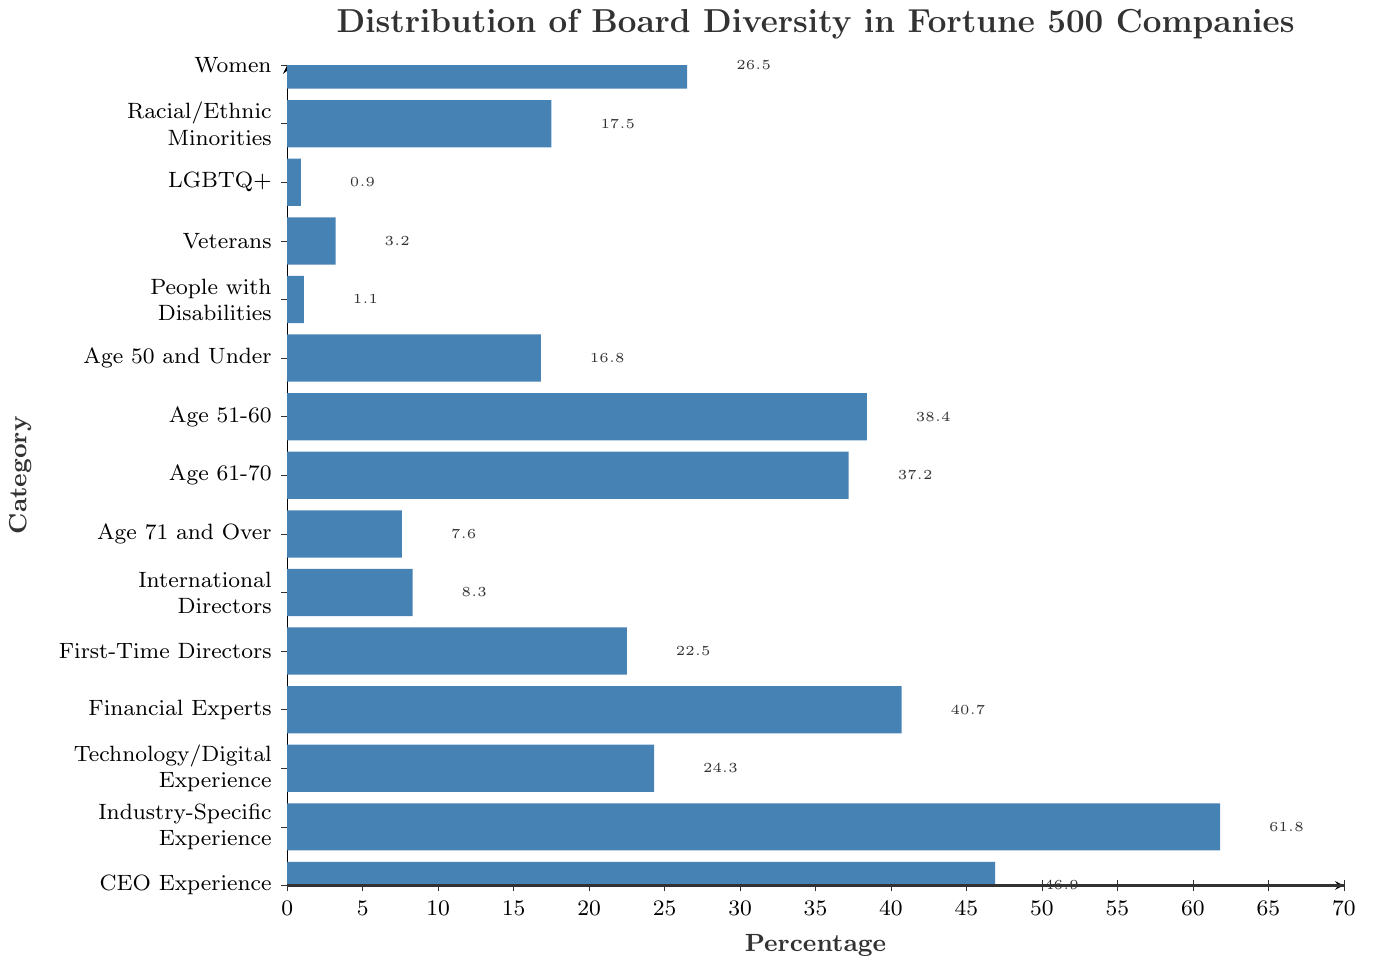Which category has the highest percentage? The highest bar represents the category with the highest percentage. The "Industry-Specific Experience" category has the highest bar at 61.8%.
Answer: Industry-Specific Experience What is the total percentage of directors with Age 51-60 and Age 61-70? Add the percentages of directors with Age 51-60 (38.4%) and Age 61-70 (37.2%). The sum is 38.4 + 37.2 = 75.6%.
Answer: 75.6% Compare the percentage of Women with that of Racial/Ethnic Minorities. Which is higher, and by how much? The percentage of Women is 26.5%, and that of Racial/Ethnic Minorities is 17.5%. The difference is 26.5 - 17.5 = 9%. Women have a higher percentage by 9%.
Answer: Women are higher by 9% Which category has the lowest representation? The shortest bar represents the category with the lowest percentage, which is the LGBTQ+ category at 0.9%.
Answer: LGBTQ+ Is the percentage of First-Time Directors greater than or less than the percentage of Financial Experts? The bar for First-Time Directors is 22.5%, and the bar for Financial Experts is 40.7%. Therefore, the percentage of First-Time Directors is less than that of Financial Experts.
Answer: Less than What percentage of categories have more than 20% representation? Identify the categories with bars extending beyond the 20% mark: Women (26.5%), Age 51-60 (38.4%), Age 61-70 (37.2%), Financial Experts (40.7%), Technology/Digital Experience (24.3%), Industry-Specific Experience (61.8%), CEO Experience (46.9%), and First-Time Directors (22.5%), totaling to 8 categories out of 15, or 8/15 * 100% = 53.3%.
Answer: 53.3% What is the difference in representation between International Directors and those Age 71 and Over? Subtract the percentage of Age 71 and Over (7.6%) from that of International Directors (8.3%). The difference is 8.3 - 7.6 = 0.7%.
Answer: 0.7% How does the representation of Veterans compare to that of People with Disabilities and LGBTQ+ combined? The percentage of Veterans is 3.2%. The combined percentage of People with Disabilities (1.1%) and LGBTQ+ (0.9%) is 1.1 + 0.9 = 2%. 3.2% (Veterans) is higher than 2% (combined).
Answer: Veterans are higher by 1.2% Which age group has the highest percentage, and what is its value? Among "Age 50 and Under", "Age 51-60", "Age 61-70", and "Age 71 and Over", the age group "Age 51-60" has the highest percentage at 38.4%.
Answer: Age 51-60, 38.4% 